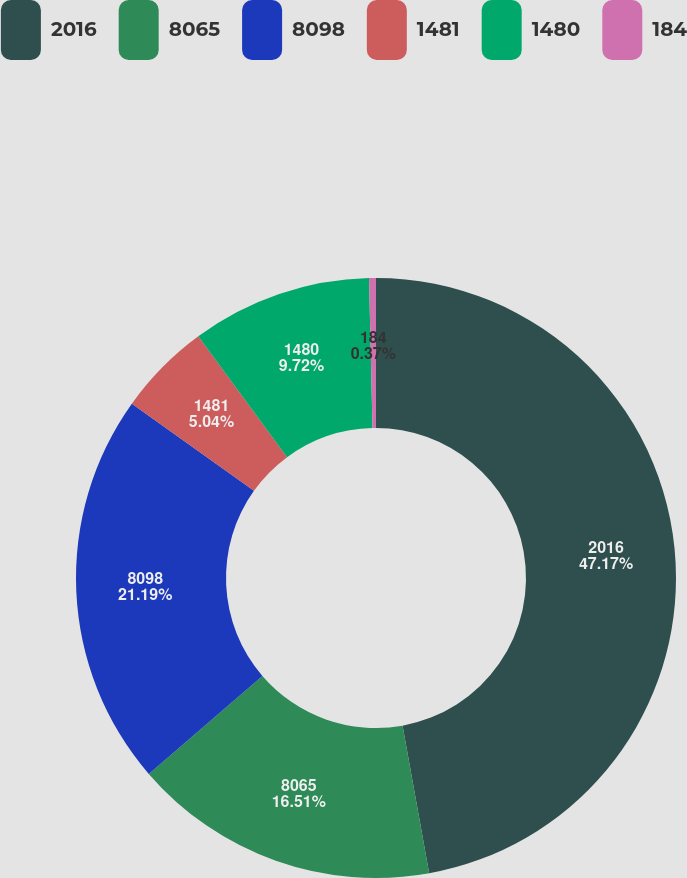<chart> <loc_0><loc_0><loc_500><loc_500><pie_chart><fcel>2016<fcel>8065<fcel>8098<fcel>1481<fcel>1480<fcel>184<nl><fcel>47.16%<fcel>16.51%<fcel>21.19%<fcel>5.04%<fcel>9.72%<fcel>0.37%<nl></chart> 